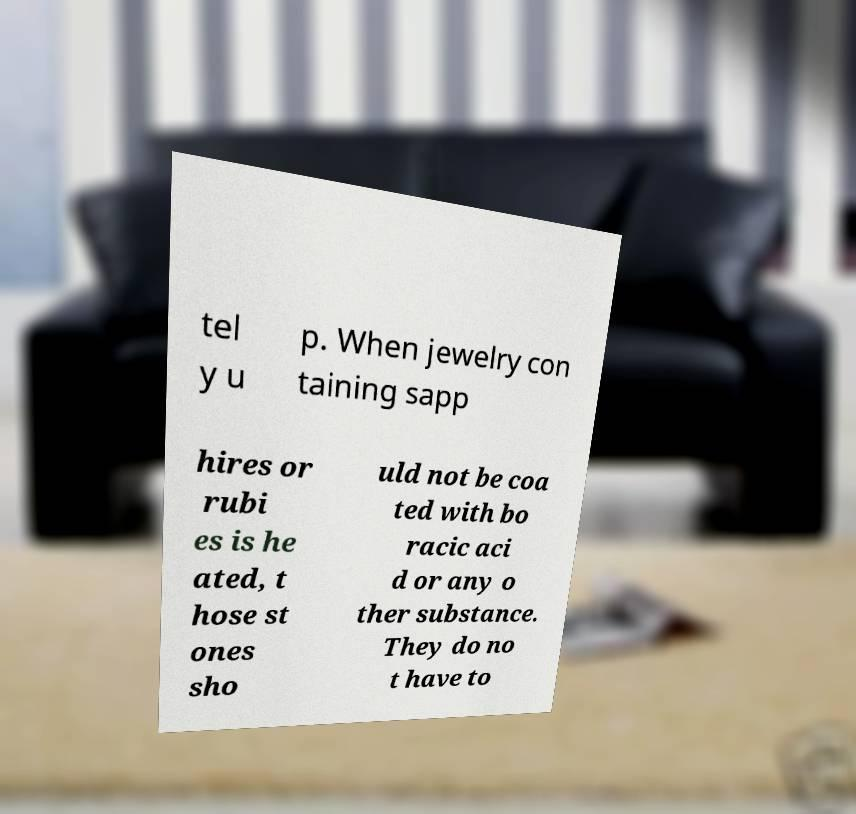Can you accurately transcribe the text from the provided image for me? tel y u p. When jewelry con taining sapp hires or rubi es is he ated, t hose st ones sho uld not be coa ted with bo racic aci d or any o ther substance. They do no t have to 